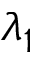Convert formula to latex. <formula><loc_0><loc_0><loc_500><loc_500>\lambda _ { 1 }</formula> 